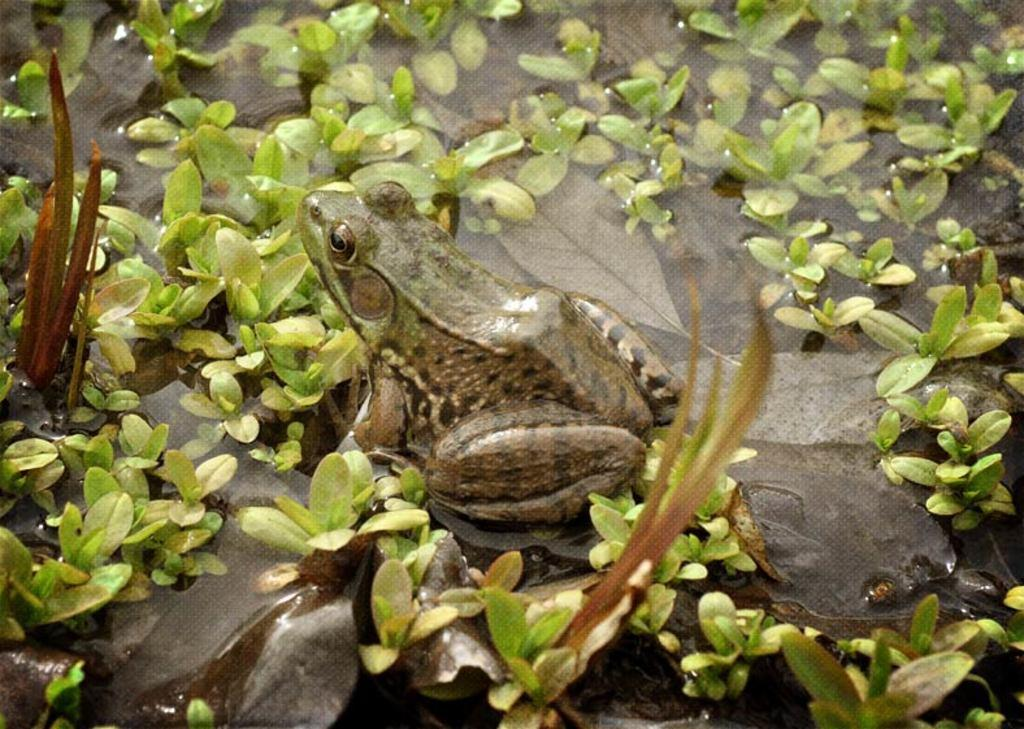What type of animal is in the image? There is a frog in the image. What else can be seen in the image besides the frog? There are plants in the image. How are the plants positioned in relation to the water? The plants are on the water. What type of hat is the frog wearing in the image? There is no hat present in the image; the frog is not wearing any clothing or accessories. 